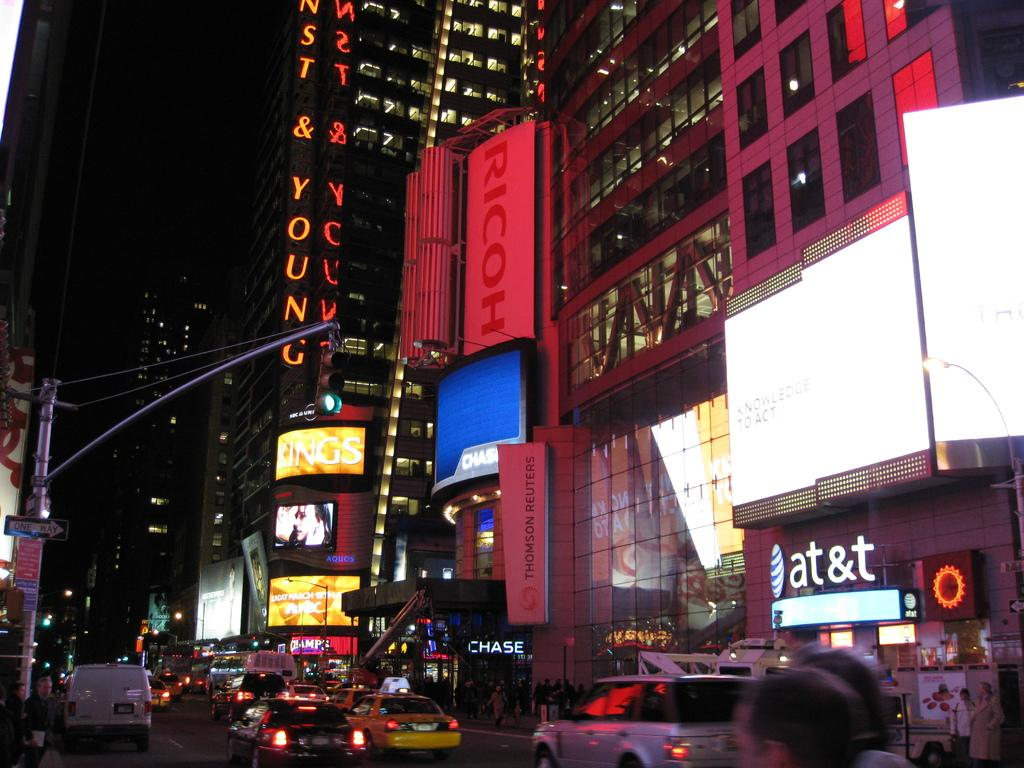<image>
Create a compact narrative representing the image presented. a city area with an at&t store there 